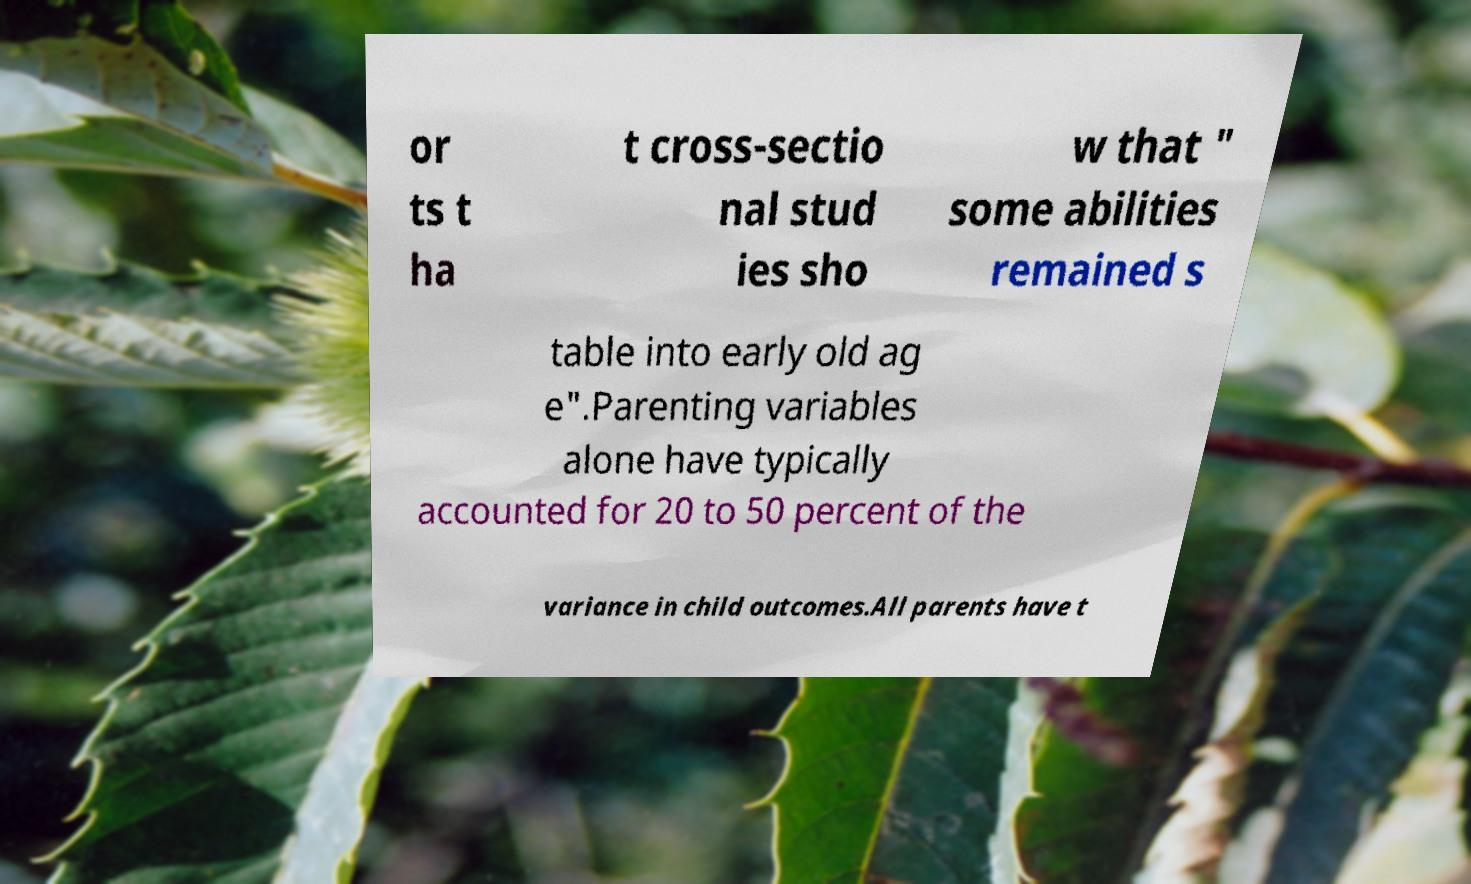Can you accurately transcribe the text from the provided image for me? or ts t ha t cross-sectio nal stud ies sho w that " some abilities remained s table into early old ag e".Parenting variables alone have typically accounted for 20 to 50 percent of the variance in child outcomes.All parents have t 